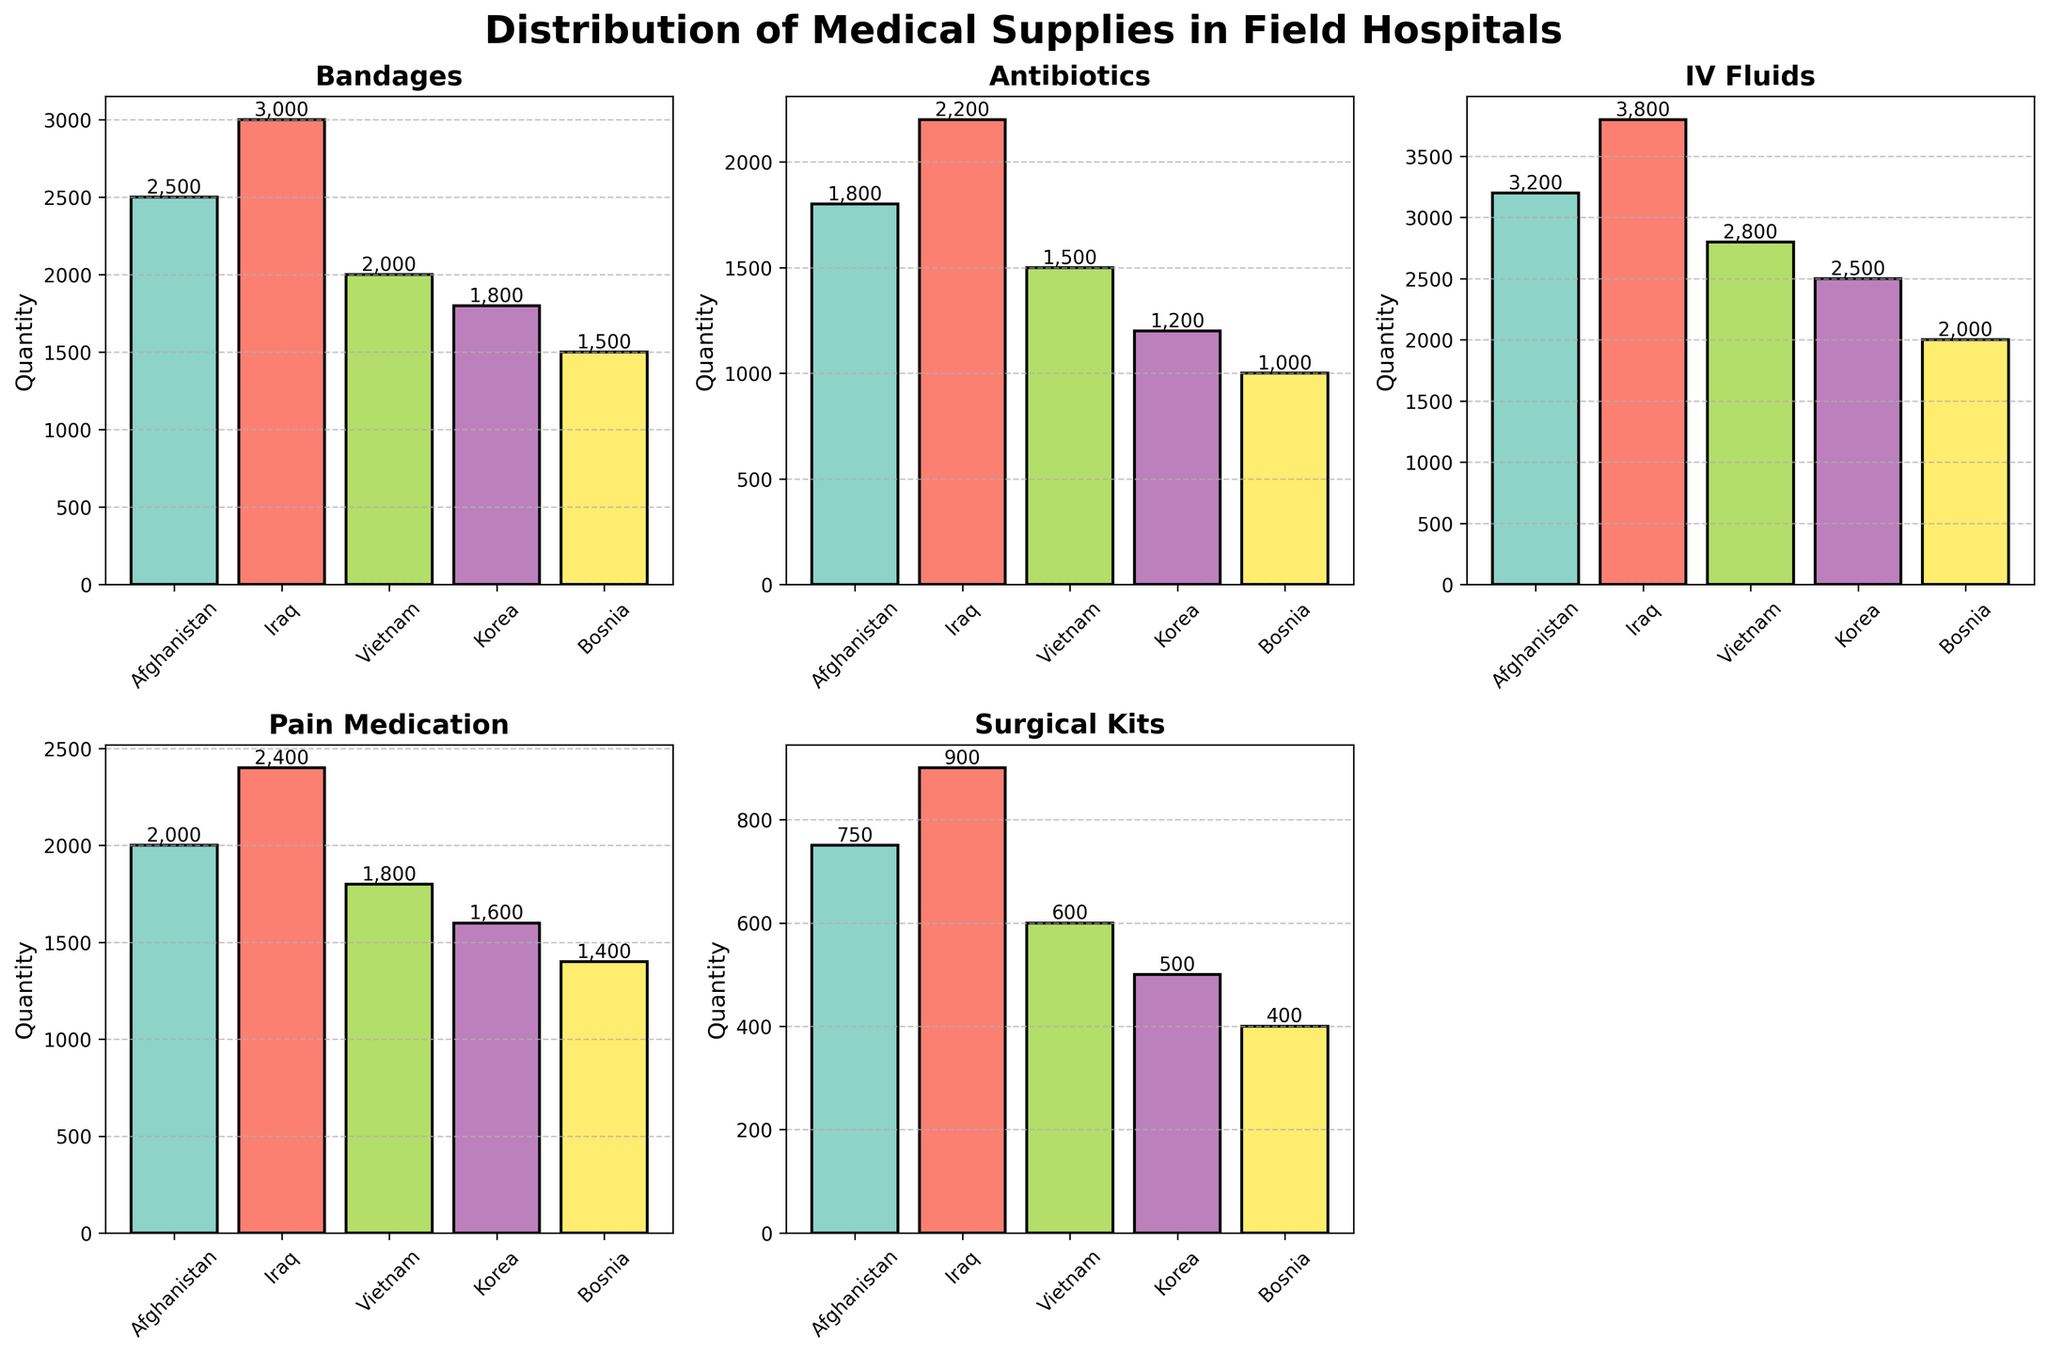What is the title of the figure? The title is located at the top of the figure and is often the most prominent text. It gives an overview of what the figure represents.
Answer: Distribution of Medical Supplies in Field Hospitals Which war zone used the most bandages? By comparing the heights of the bars in the 'Bandages' subplot, we can identify the tallest bar.
Answer: Iraq Among the different war zones, which two had the smallest quantities of surgical kits? We need to identify and compare the bars in the 'Surgical Kits' subplot. The smallest values will have the shortest bars.
Answer: Bosnia and Korea What is the total quantity of IV Fluids used across all war zones? Add up the values for IV Fluids across all war zones: 3200 (Afghanistan) + 3800 (Iraq) + 2800 (Vietnam) + 2500 (Korea) + 2000 (Bosnia).
Answer: 14300 How does the quantity of pain medication used in Iraq compare to that used in Afghanistan? Locate and compare the bars for both Iraq and Afghanistan in the 'Pain Medication' subplot. Iraq's bar is taller than Afghanistan's.
Answer: Iraq uses more Which supply has the highest overall quantity across all war zones? Observe each subplot and identify the supply category with the overall tallest bars. IV Fluids has consistently tall bars across all war zones.
Answer: IV Fluids What's the difference in the number of antibiotics used between Iraq and Vietnam? Subtract Vietnam's value for antibiotics from that of Iraq: 2200 (Iraq) - 1500 (Vietnam).
Answer: 700 In which war zones were more than 2500 units of IV Fluids used? Examine the bars in the IV Fluids subplot to see which ones exceed the 2500-unit mark.
Answer: Afghanistan, Iraq Between Afghanistan and Korea, which war zone utilized more surgical kits and by how much? Compare the bars for surgical kits in the 'Surgical Kits' subplot, and calculate the difference: 750 (Afghanistan) - 500 (Korea).
Answer: Afghanistan by 250 units What is the average quantity of pain medication used across all the war zones? Sum the quantities of pain medication for all war zones and divide by the number of war zones: (2000 + 2400 + 1800 + 1600 + 1400) / 5.
Answer: 1840 